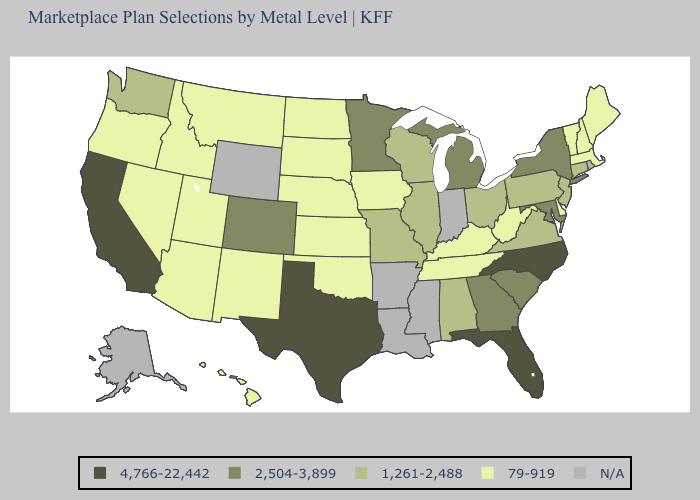Does South Dakota have the lowest value in the MidWest?
Concise answer only. Yes. What is the value of Kentucky?
Answer briefly. 79-919. What is the value of Ohio?
Write a very short answer. 1,261-2,488. How many symbols are there in the legend?
Keep it brief. 5. Name the states that have a value in the range 4,766-22,442?
Be succinct. California, Florida, North Carolina, Texas. Name the states that have a value in the range 1,261-2,488?
Be succinct. Alabama, Connecticut, Illinois, Missouri, New Jersey, Ohio, Pennsylvania, Virginia, Washington, Wisconsin. Does Ohio have the lowest value in the USA?
Concise answer only. No. What is the value of Florida?
Keep it brief. 4,766-22,442. What is the value of New York?
Keep it brief. 2,504-3,899. How many symbols are there in the legend?
Concise answer only. 5. What is the value of New Jersey?
Be succinct. 1,261-2,488. Among the states that border Ohio , which have the lowest value?
Concise answer only. Kentucky, West Virginia. Does the map have missing data?
Quick response, please. Yes. Which states have the lowest value in the West?
Concise answer only. Arizona, Hawaii, Idaho, Montana, Nevada, New Mexico, Oregon, Utah. 